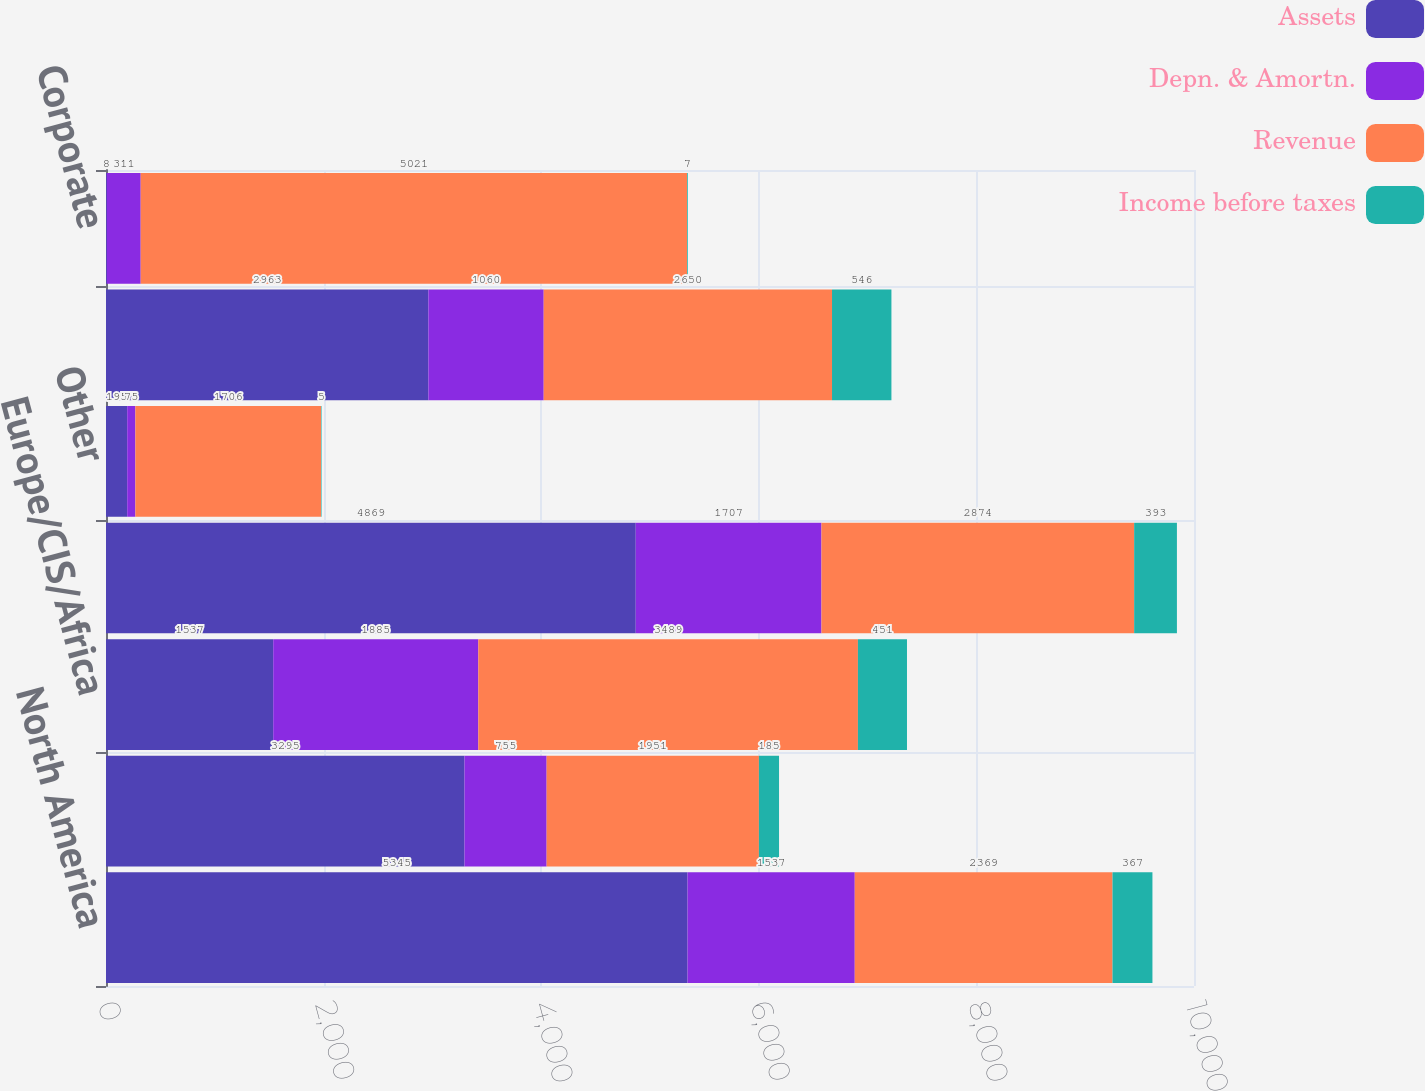<chart> <loc_0><loc_0><loc_500><loc_500><stacked_bar_chart><ecel><fcel>North America<fcel>Latin America<fcel>Europe/CIS/Africa<fcel>Middle East & Asia<fcel>Other<fcel>WESTERNGECO<fcel>Corporate<nl><fcel>Assets<fcel>5345<fcel>3295<fcel>1537<fcel>4869<fcel>195<fcel>2963<fcel>8<nl><fcel>Depn. & Amortn.<fcel>1537<fcel>755<fcel>1885<fcel>1707<fcel>75<fcel>1060<fcel>311<nl><fcel>Revenue<fcel>2369<fcel>1951<fcel>3489<fcel>2874<fcel>1706<fcel>2650<fcel>5021<nl><fcel>Income before taxes<fcel>367<fcel>185<fcel>451<fcel>393<fcel>5<fcel>546<fcel>7<nl></chart> 